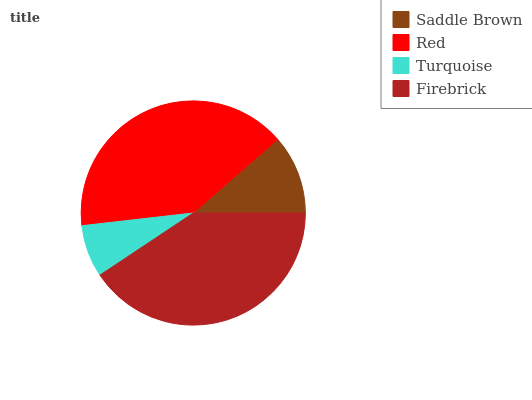Is Turquoise the minimum?
Answer yes or no. Yes. Is Firebrick the maximum?
Answer yes or no. Yes. Is Red the minimum?
Answer yes or no. No. Is Red the maximum?
Answer yes or no. No. Is Red greater than Saddle Brown?
Answer yes or no. Yes. Is Saddle Brown less than Red?
Answer yes or no. Yes. Is Saddle Brown greater than Red?
Answer yes or no. No. Is Red less than Saddle Brown?
Answer yes or no. No. Is Red the high median?
Answer yes or no. Yes. Is Saddle Brown the low median?
Answer yes or no. Yes. Is Saddle Brown the high median?
Answer yes or no. No. Is Turquoise the low median?
Answer yes or no. No. 